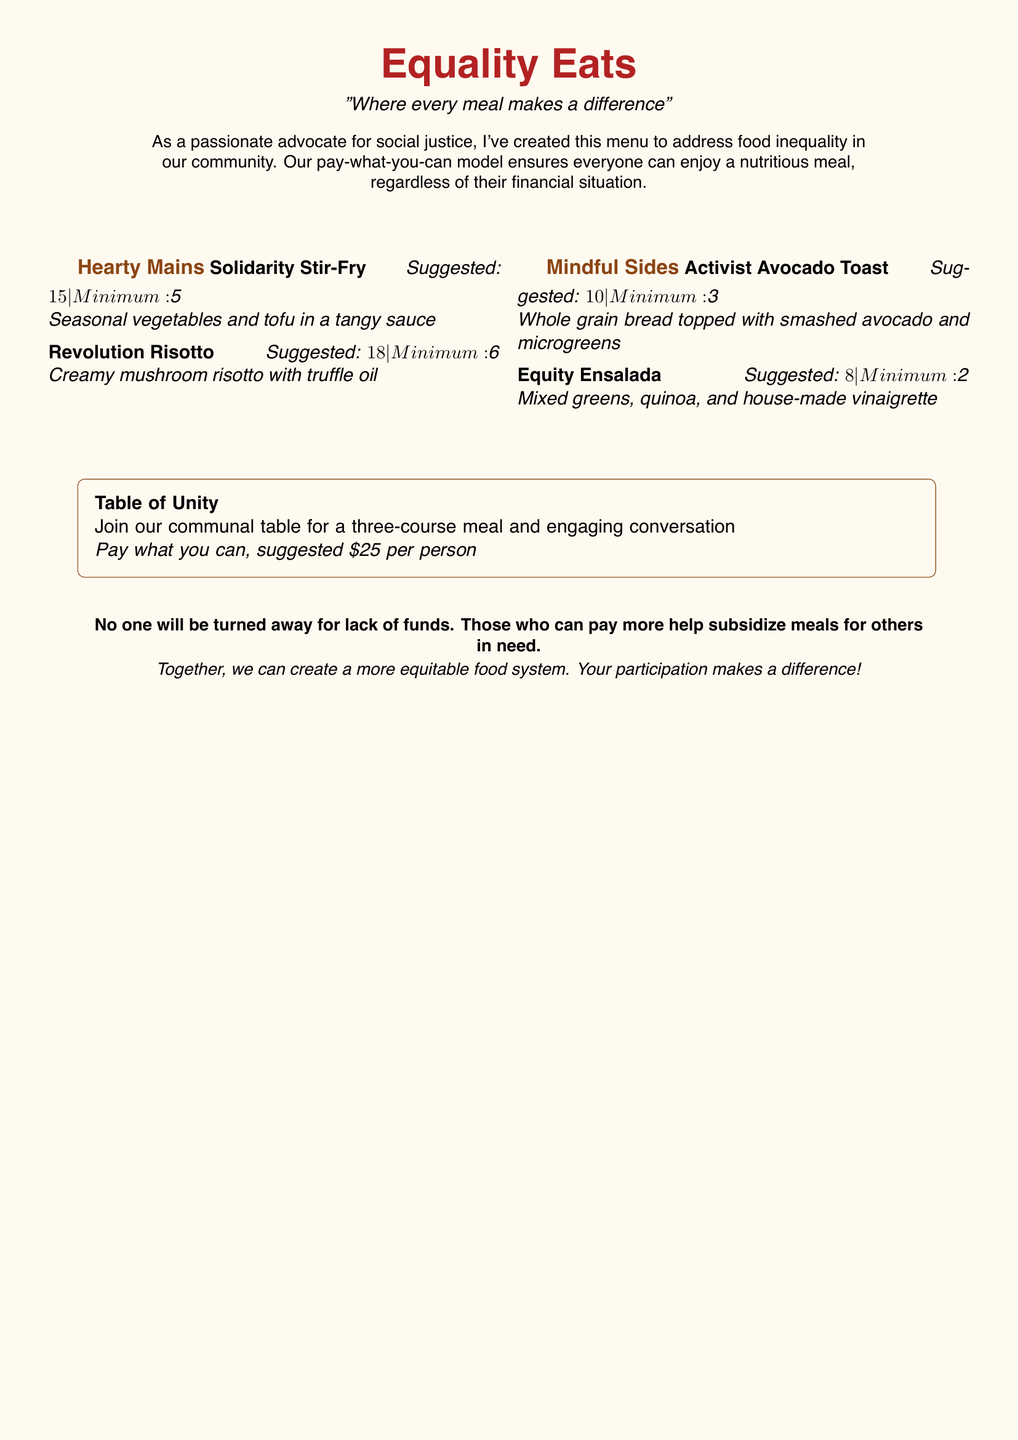What is the name of the menu? The menu is titled "Equality Eats," as stated at the top of the document.
Answer: Equality Eats What price is suggested for the Solidarity Stir-Fry? The suggested price for the Solidarity Stir-Fry is listed in the menu item details.
Answer: $15 What is the minimum payment for the Revolution Risotto? The minimum payment is provided alongside the suggested price for the Revolution Risotto.
Answer: $6 What is included in the Table of Unity meal? The Table of Unity includes a three-course meal and engaging conversation, as described in the document.
Answer: Three-course meal and engaging conversation What is the suggested price for the communal meal? The suggested price for the communal meal is stated within the description of the Table of Unity.
Answer: $25 How much does the Activist Avocado Toast cost at minimum? The minimum cost for the Activist Avocado Toast is provided next to the dish's description.
Answer: $3 How many main dishes are listed in the menu? The menu lists a total of two hearty mains under the Hearty Mains section.
Answer: 2 What is the core idea behind the pay-what-you-can model? The document explains that the pay-what-you-can model aims to address food inequality in the community.
Answer: Address food inequality Is anyone turned away for lack of funds? The document explicitly states the policy regarding financial constraints on meal availability.
Answer: No 